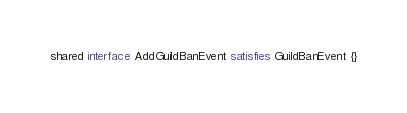<code> <loc_0><loc_0><loc_500><loc_500><_Ceylon_>shared interface AddGuildBanEvent satisfies GuildBanEvent {}</code> 